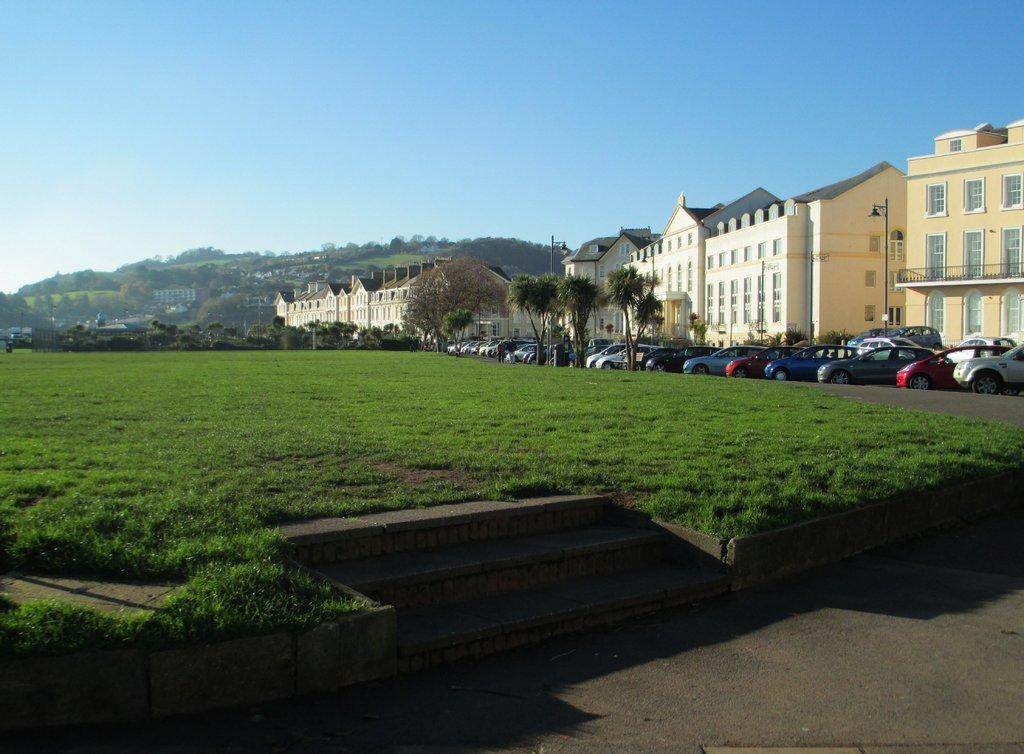What type of vehicles can be seen on the ground in the image? There are cars on the ground in the image. What type of vegetation is visible in the image? There is grass visible in the image. What architectural feature can be seen in the image? There are steps in the image. What type of structures are present in the image? There are buildings with windows in the image. What is visible in the background of the image? The sky is visible in the background of the image. What type of art can be seen on the stage in the image? There is no stage or art present in the image; it features cars, grass, steps, buildings, and the sky. How much milk is being poured by the person in the image? There is no person or milk present in the image. 